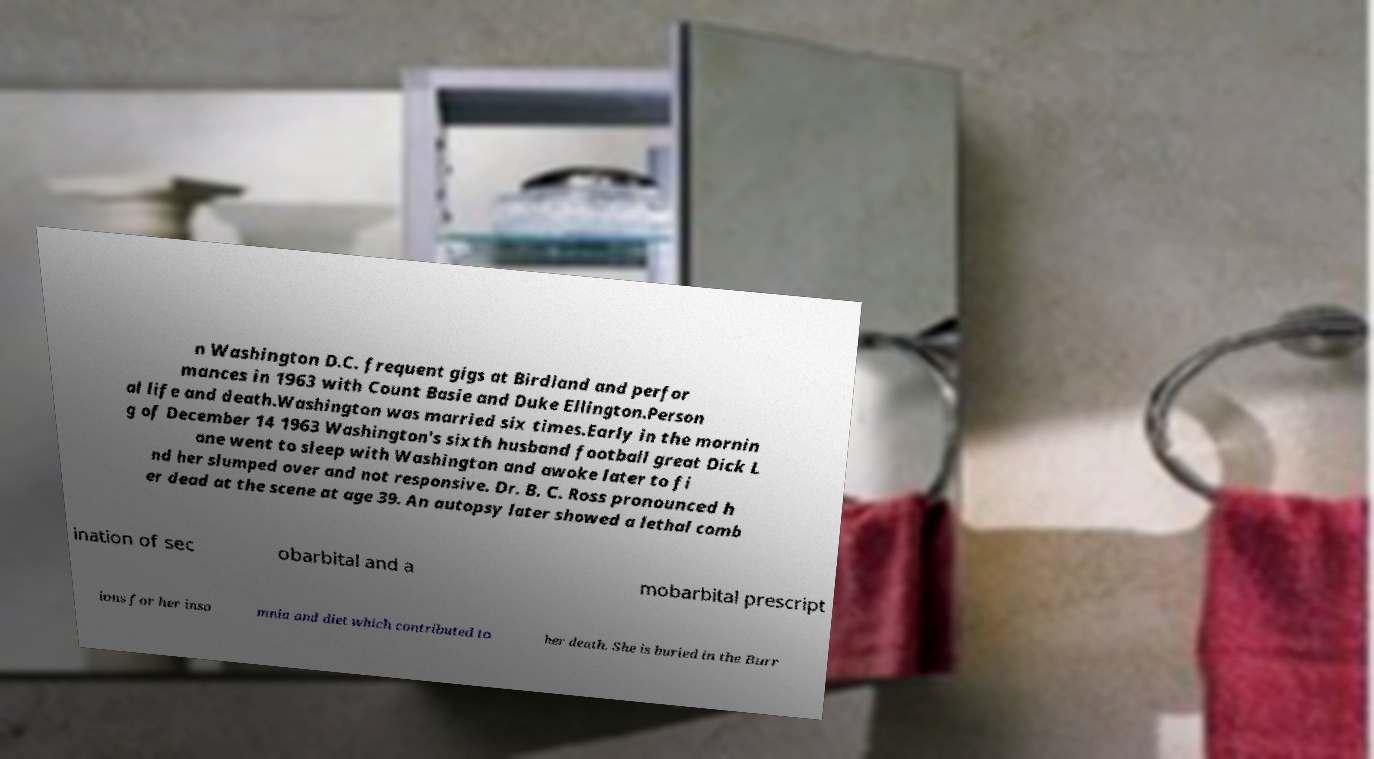Please identify and transcribe the text found in this image. n Washington D.C. frequent gigs at Birdland and perfor mances in 1963 with Count Basie and Duke Ellington.Person al life and death.Washington was married six times.Early in the mornin g of December 14 1963 Washington's sixth husband football great Dick L ane went to sleep with Washington and awoke later to fi nd her slumped over and not responsive. Dr. B. C. Ross pronounced h er dead at the scene at age 39. An autopsy later showed a lethal comb ination of sec obarbital and a mobarbital prescript ions for her inso mnia and diet which contributed to her death. She is buried in the Burr 